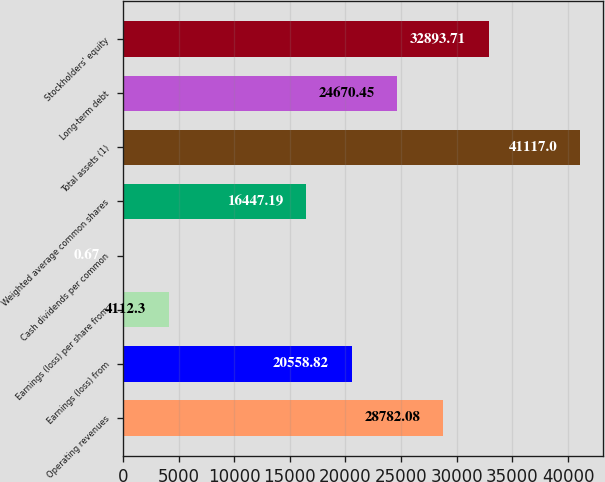<chart> <loc_0><loc_0><loc_500><loc_500><bar_chart><fcel>Operating revenues<fcel>Earnings (loss) from<fcel>Earnings (loss) per share from<fcel>Cash dividends per common<fcel>Weighted average common shares<fcel>Total assets (1)<fcel>Long-term debt<fcel>Stockholders' equity<nl><fcel>28782.1<fcel>20558.8<fcel>4112.3<fcel>0.67<fcel>16447.2<fcel>41117<fcel>24670.5<fcel>32893.7<nl></chart> 